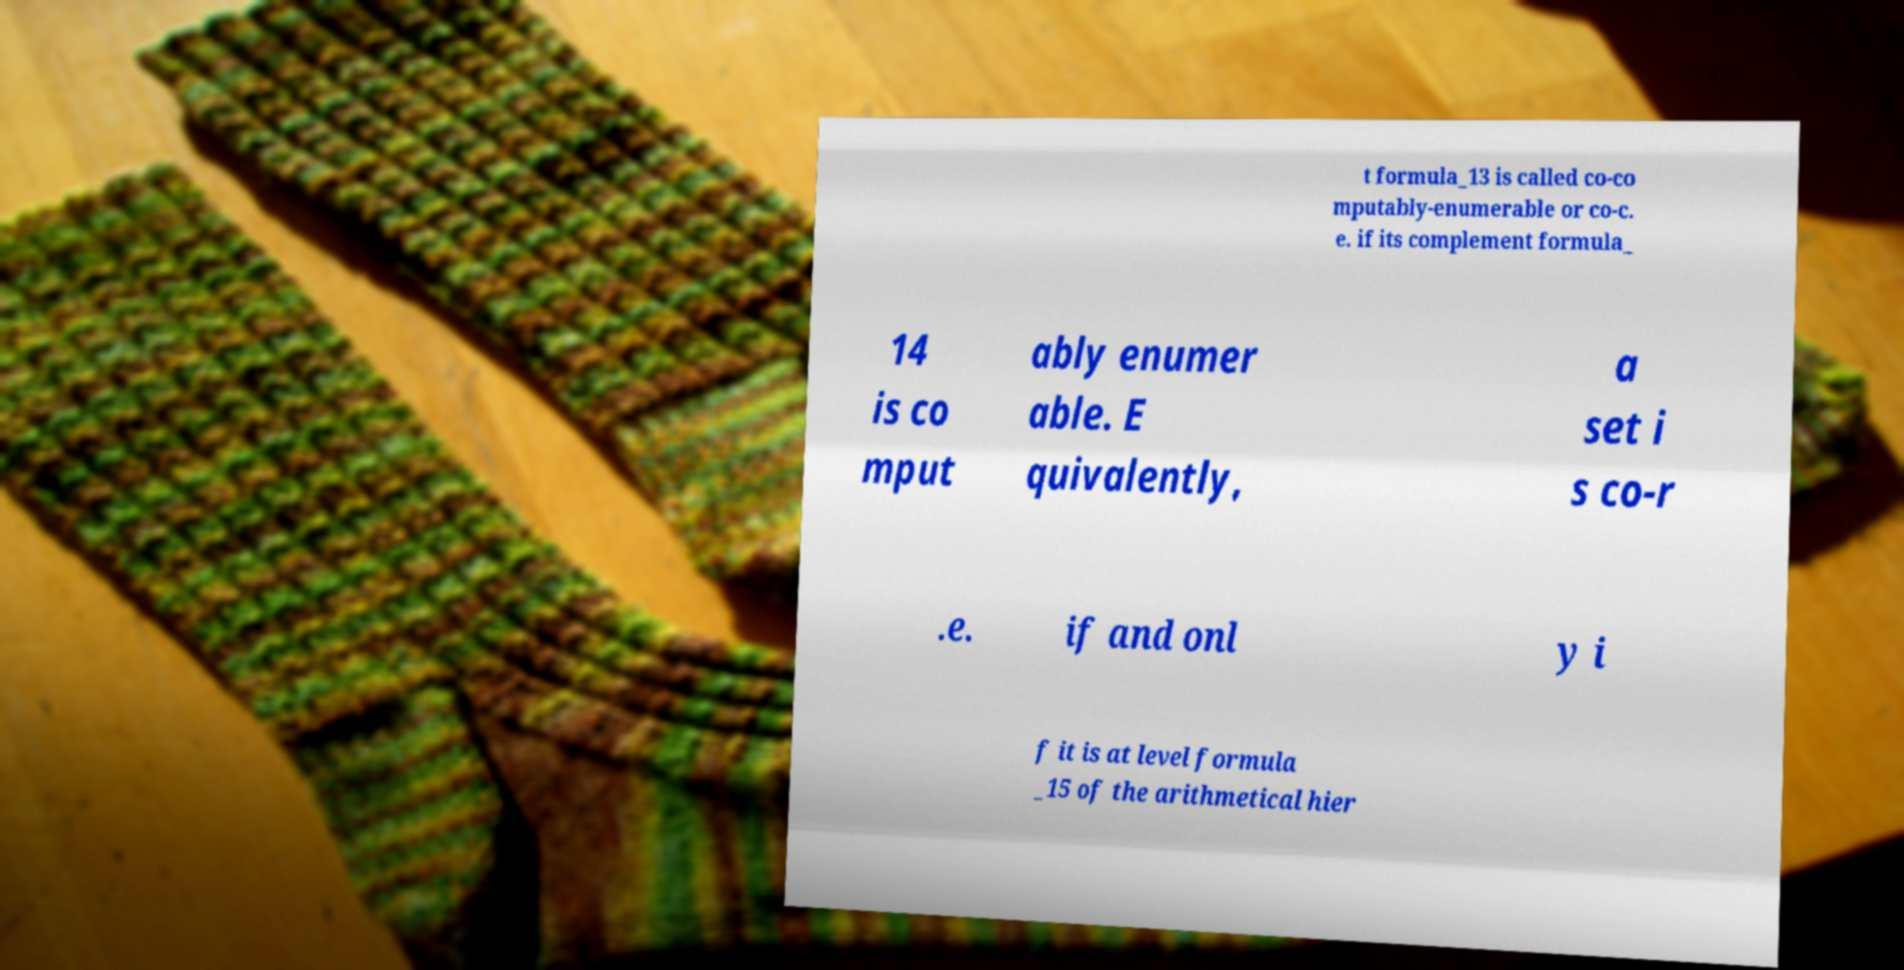Please read and relay the text visible in this image. What does it say? t formula_13 is called co-co mputably-enumerable or co-c. e. if its complement formula_ 14 is co mput ably enumer able. E quivalently, a set i s co-r .e. if and onl y i f it is at level formula _15 of the arithmetical hier 